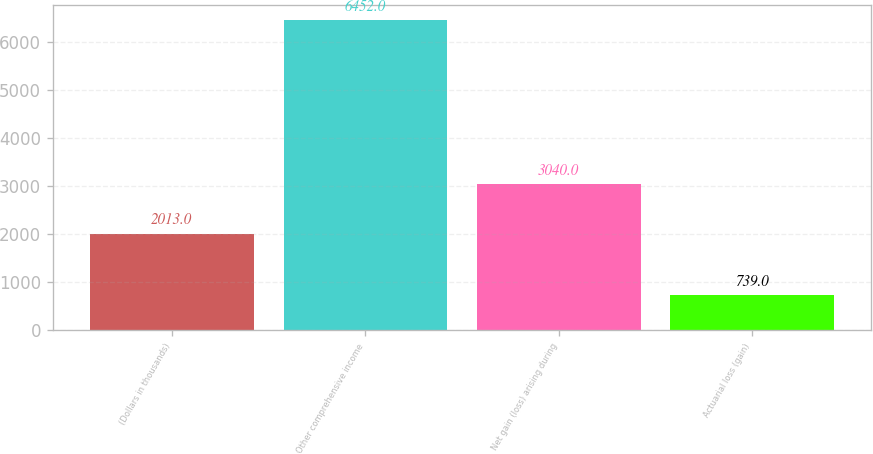<chart> <loc_0><loc_0><loc_500><loc_500><bar_chart><fcel>(Dollars in thousands)<fcel>Other comprehensive income<fcel>Net gain (loss) arising during<fcel>Actuarial loss (gain)<nl><fcel>2013<fcel>6452<fcel>3040<fcel>739<nl></chart> 